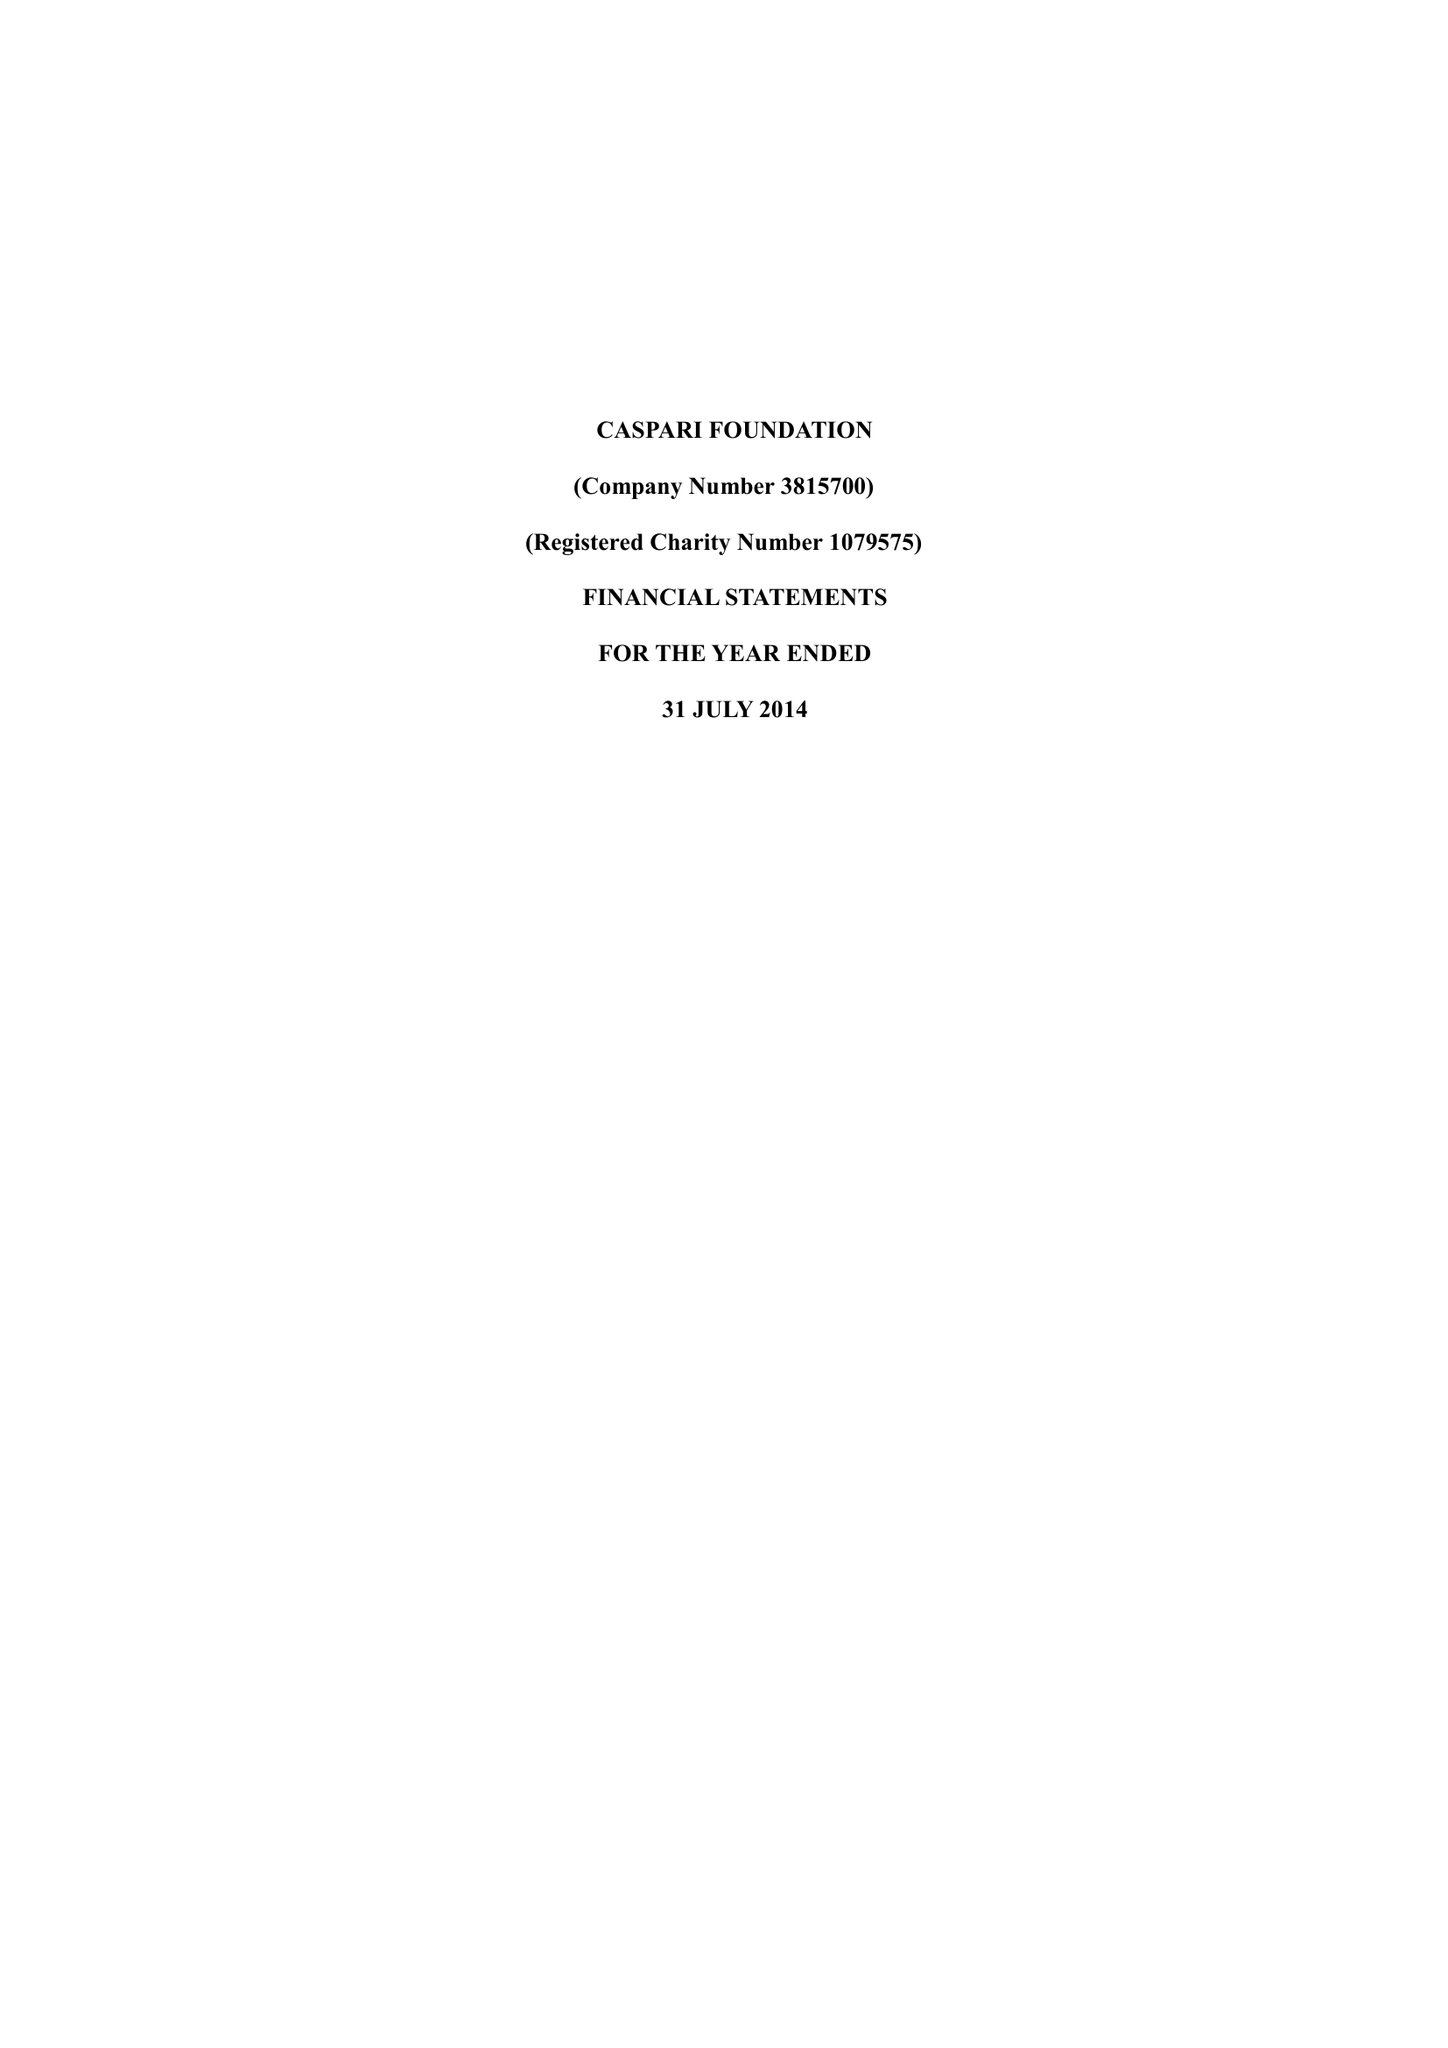What is the value for the address__street_line?
Answer the question using a single word or phrase. 225-229 SEVEN SISTERS ROAD 